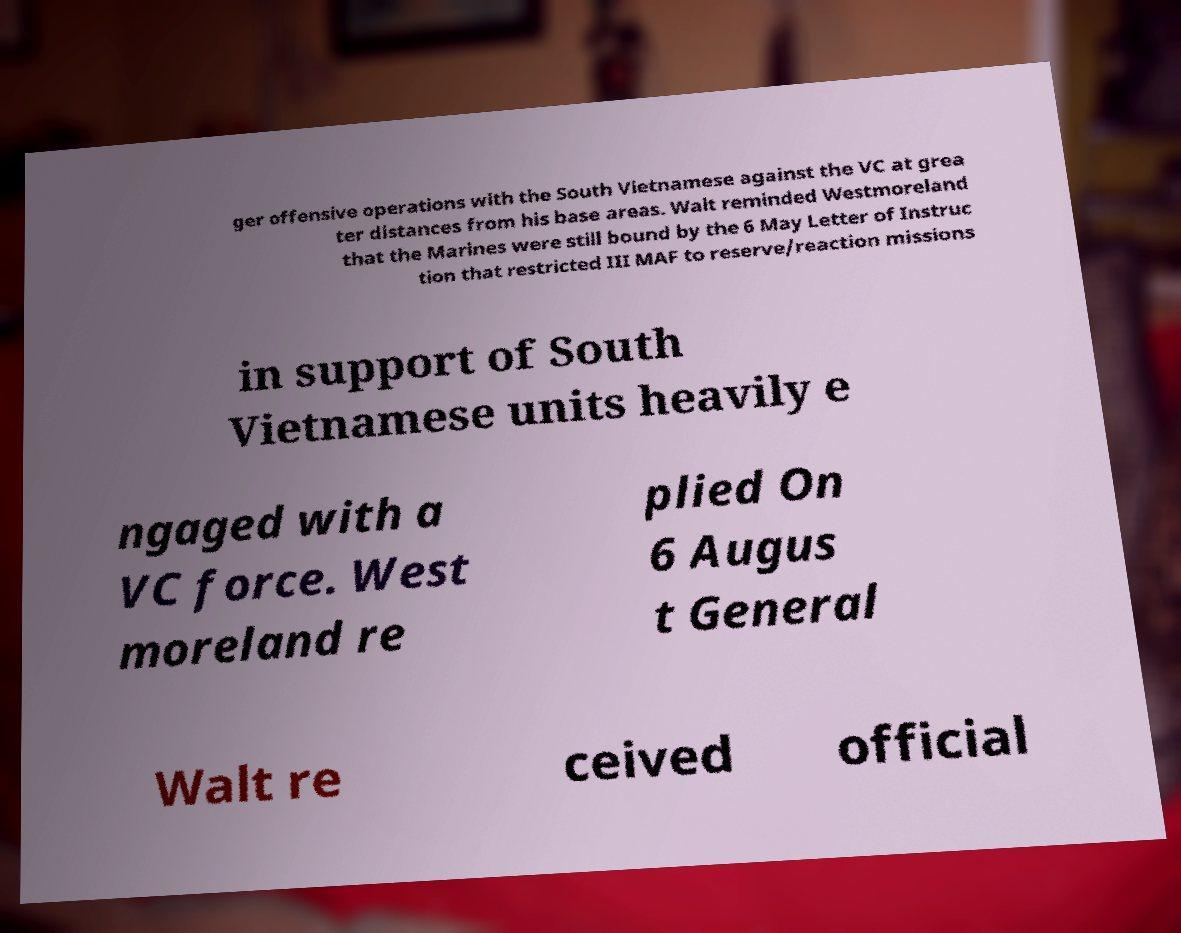For documentation purposes, I need the text within this image transcribed. Could you provide that? ger offensive operations with the South Vietnamese against the VC at grea ter distances from his base areas. Walt reminded Westmoreland that the Marines were still bound by the 6 May Letter of Instruc tion that restricted III MAF to reserve/reaction missions in support of South Vietnamese units heavily e ngaged with a VC force. West moreland re plied On 6 Augus t General Walt re ceived official 